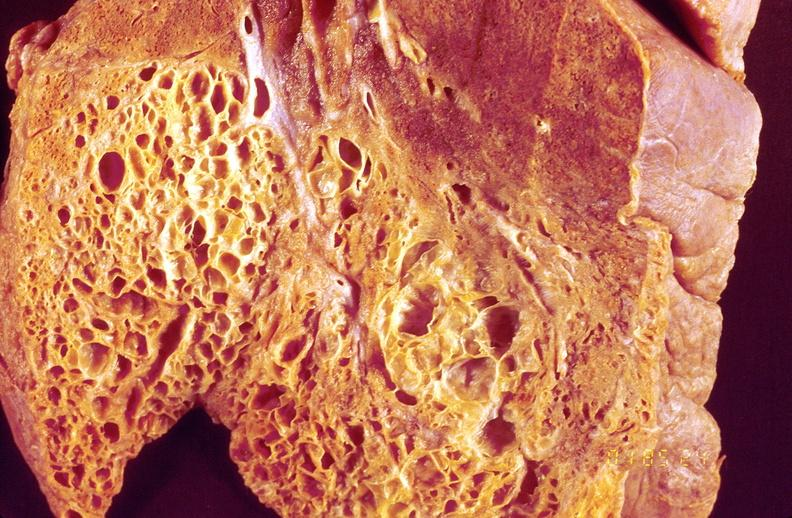does this image show lung fibrosis, scleroderma?
Answer the question using a single word or phrase. Yes 